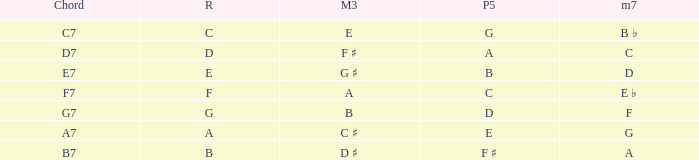What is the Chord with a Minor that is seventh of f? G7. 